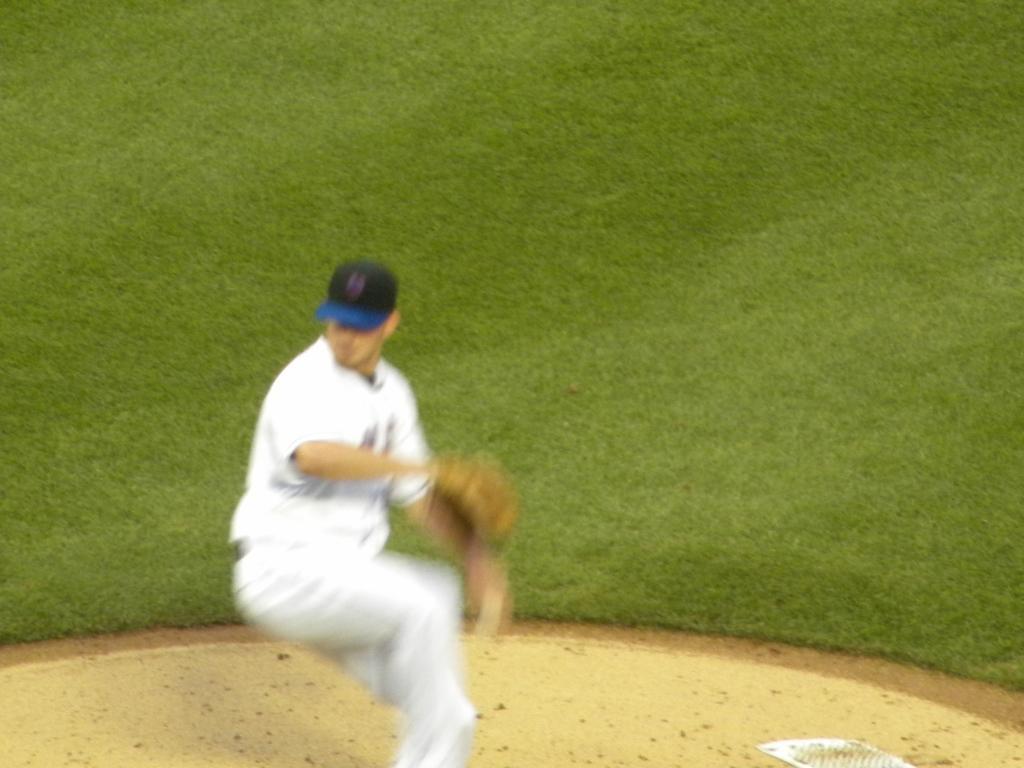Could you give a brief overview of what you see in this image? In front of the image there is a person wearing a cap. At the bottom of the image there is grass on the surface. 